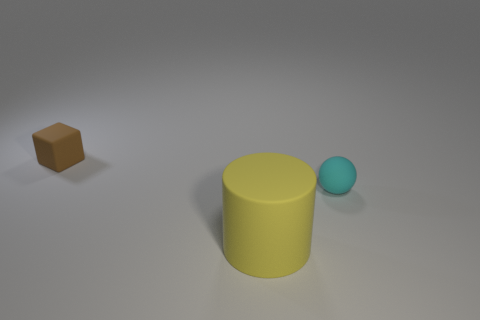How many other small brown rubber things are the same shape as the small brown rubber object?
Provide a succinct answer. 0. There is a matte object that is behind the small cyan sphere behind the matte object that is in front of the cyan sphere; what is its size?
Provide a succinct answer. Small. What number of brown objects are rubber objects or tiny balls?
Your response must be concise. 1. Is the number of small objects that are to the left of the large thing greater than the number of purple metal blocks?
Provide a succinct answer. Yes. How many yellow things have the same size as the rubber cube?
Give a very brief answer. 0. What number of objects are rubber spheres or rubber objects that are on the left side of the small cyan matte sphere?
Ensure brevity in your answer.  3. There is a matte object that is on the right side of the brown rubber cube and behind the large matte thing; what is its color?
Your answer should be very brief. Cyan. Does the yellow rubber thing have the same size as the cyan ball?
Keep it short and to the point. No. There is a rubber object in front of the small cyan object; what color is it?
Your answer should be very brief. Yellow. There is a cube that is the same size as the rubber sphere; what is its color?
Provide a short and direct response. Brown. 